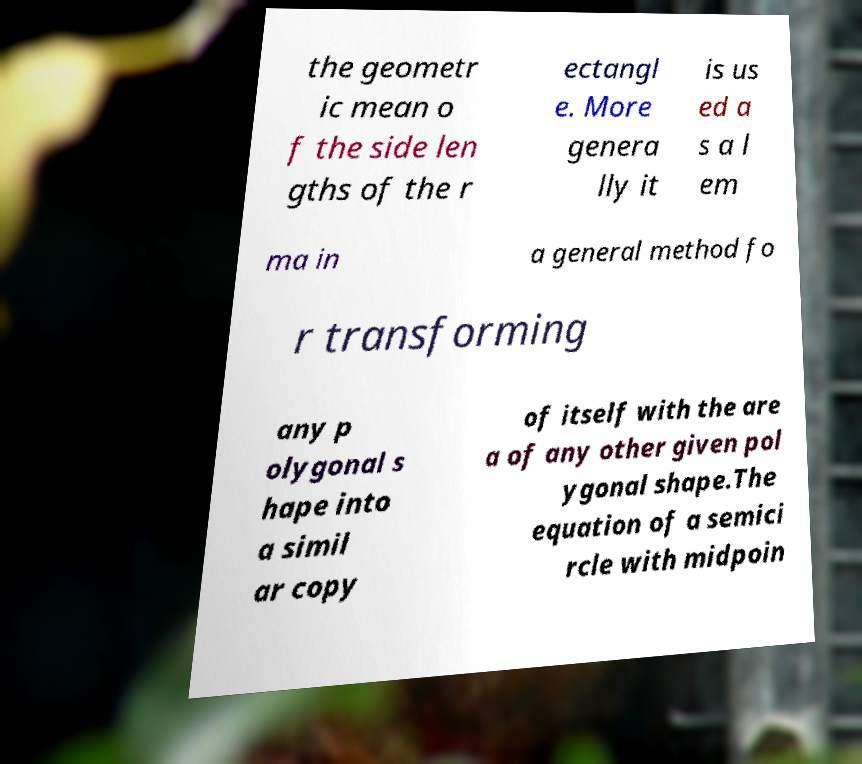Could you assist in decoding the text presented in this image and type it out clearly? the geometr ic mean o f the side len gths of the r ectangl e. More genera lly it is us ed a s a l em ma in a general method fo r transforming any p olygonal s hape into a simil ar copy of itself with the are a of any other given pol ygonal shape.The equation of a semici rcle with midpoin 